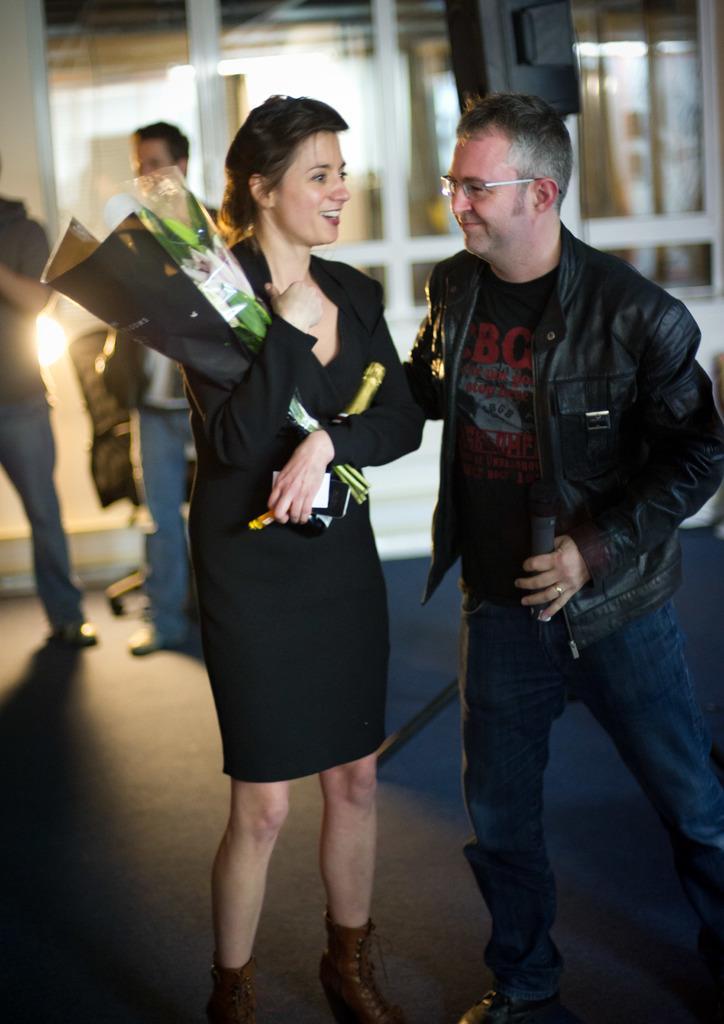Can you describe this image briefly? In this image we can see persons standing on the floor. Of them a woman is holding bouquet and beverage bottle in her hands and a man is holding mic in one of his hands. In the background we can see a store. 